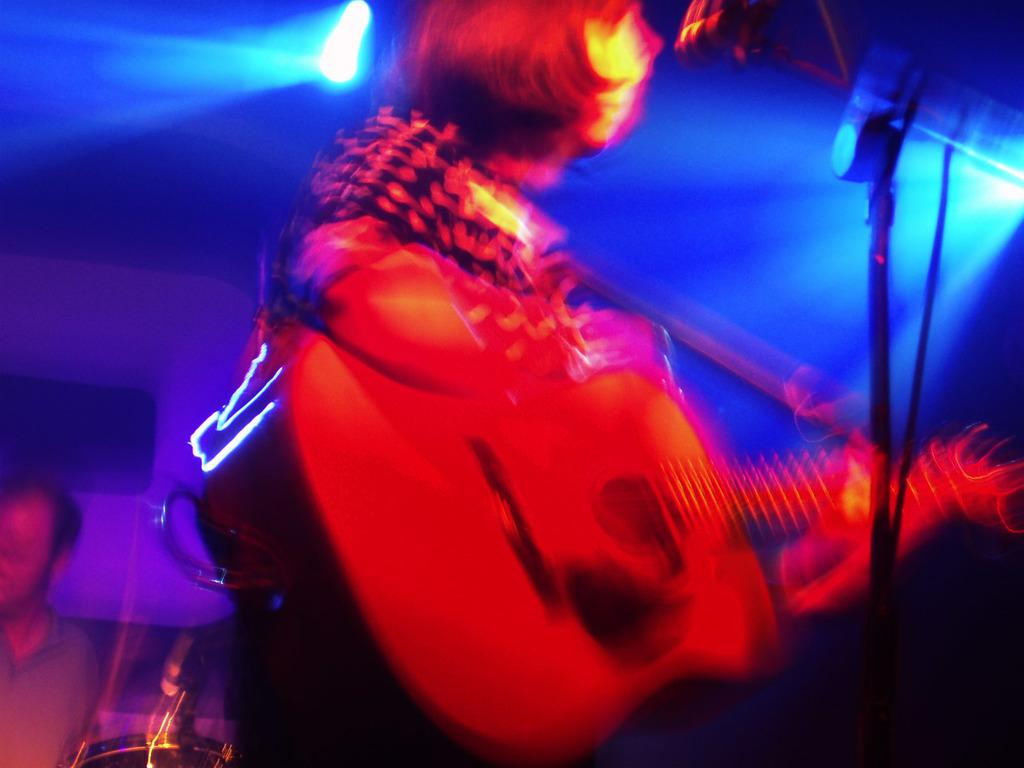What is the man in the image doing? The man is playing the guitar and singing on a microphone. What instrument is the man holding in the image? The man is holding a guitar in the image. Can you describe the background of the image? There is another person and a light source in the background of the image. How is the image quality? The image is blurry. What degree does the man have in anger management, as seen in the image? There is no indication of the man's anger management skills or degrees in the image. 